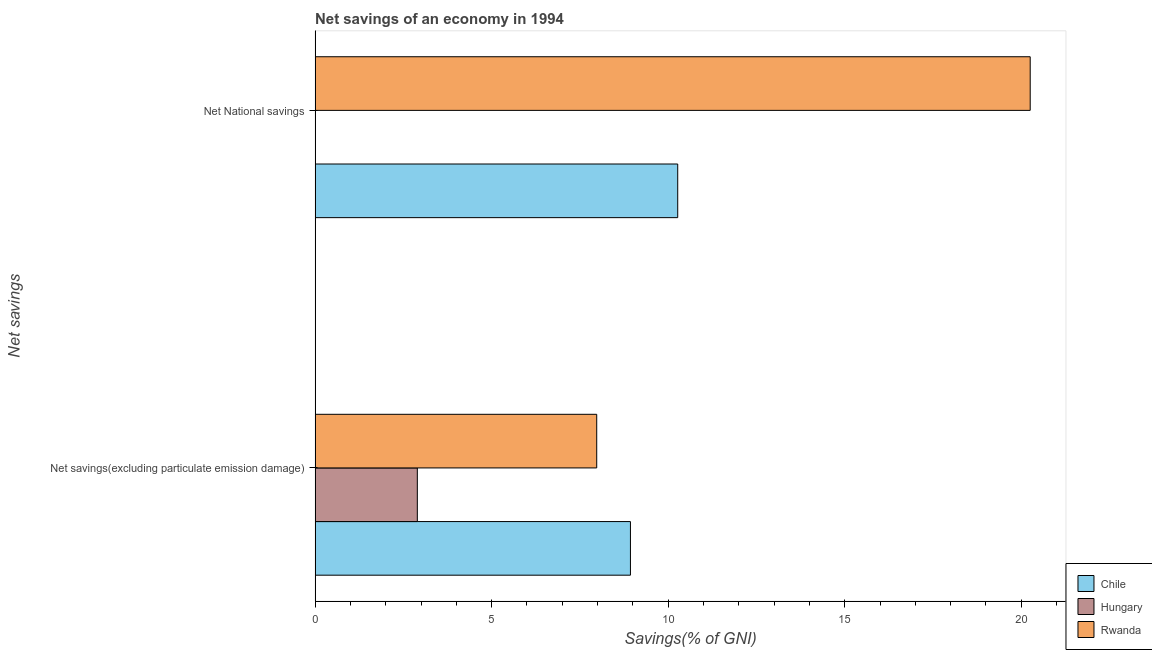Are the number of bars per tick equal to the number of legend labels?
Provide a succinct answer. No. How many bars are there on the 2nd tick from the bottom?
Your answer should be compact. 2. What is the label of the 1st group of bars from the top?
Offer a terse response. Net National savings. What is the net national savings in Chile?
Give a very brief answer. 10.27. Across all countries, what is the maximum net savings(excluding particulate emission damage)?
Provide a succinct answer. 8.93. Across all countries, what is the minimum net national savings?
Offer a terse response. 0. In which country was the net savings(excluding particulate emission damage) maximum?
Keep it short and to the point. Chile. What is the total net savings(excluding particulate emission damage) in the graph?
Your answer should be compact. 19.8. What is the difference between the net national savings in Rwanda and that in Chile?
Give a very brief answer. 9.98. What is the difference between the net national savings in Chile and the net savings(excluding particulate emission damage) in Hungary?
Your response must be concise. 7.37. What is the average net savings(excluding particulate emission damage) per country?
Your answer should be very brief. 6.6. What is the difference between the net savings(excluding particulate emission damage) and net national savings in Rwanda?
Make the answer very short. -12.28. In how many countries, is the net savings(excluding particulate emission damage) greater than 12 %?
Keep it short and to the point. 0. What is the ratio of the net national savings in Chile to that in Rwanda?
Make the answer very short. 0.51. Is the net national savings in Chile less than that in Rwanda?
Your response must be concise. Yes. In how many countries, is the net national savings greater than the average net national savings taken over all countries?
Make the answer very short. 2. Are all the bars in the graph horizontal?
Provide a short and direct response. Yes. What is the difference between two consecutive major ticks on the X-axis?
Offer a terse response. 5. Does the graph contain any zero values?
Offer a very short reply. Yes. Does the graph contain grids?
Your answer should be compact. No. What is the title of the graph?
Your response must be concise. Net savings of an economy in 1994. What is the label or title of the X-axis?
Make the answer very short. Savings(% of GNI). What is the label or title of the Y-axis?
Your response must be concise. Net savings. What is the Savings(% of GNI) of Chile in Net savings(excluding particulate emission damage)?
Offer a terse response. 8.93. What is the Savings(% of GNI) in Hungary in Net savings(excluding particulate emission damage)?
Your answer should be compact. 2.9. What is the Savings(% of GNI) of Rwanda in Net savings(excluding particulate emission damage)?
Offer a terse response. 7.98. What is the Savings(% of GNI) of Chile in Net National savings?
Make the answer very short. 10.27. What is the Savings(% of GNI) in Rwanda in Net National savings?
Your answer should be compact. 20.25. Across all Net savings, what is the maximum Savings(% of GNI) in Chile?
Your answer should be compact. 10.27. Across all Net savings, what is the maximum Savings(% of GNI) of Hungary?
Offer a very short reply. 2.9. Across all Net savings, what is the maximum Savings(% of GNI) of Rwanda?
Give a very brief answer. 20.25. Across all Net savings, what is the minimum Savings(% of GNI) in Chile?
Provide a short and direct response. 8.93. Across all Net savings, what is the minimum Savings(% of GNI) of Rwanda?
Give a very brief answer. 7.98. What is the total Savings(% of GNI) in Chile in the graph?
Your answer should be compact. 19.2. What is the total Savings(% of GNI) of Hungary in the graph?
Your answer should be very brief. 2.9. What is the total Savings(% of GNI) of Rwanda in the graph?
Ensure brevity in your answer.  28.23. What is the difference between the Savings(% of GNI) in Chile in Net savings(excluding particulate emission damage) and that in Net National savings?
Make the answer very short. -1.34. What is the difference between the Savings(% of GNI) in Rwanda in Net savings(excluding particulate emission damage) and that in Net National savings?
Provide a succinct answer. -12.28. What is the difference between the Savings(% of GNI) in Chile in Net savings(excluding particulate emission damage) and the Savings(% of GNI) in Rwanda in Net National savings?
Offer a terse response. -11.32. What is the difference between the Savings(% of GNI) in Hungary in Net savings(excluding particulate emission damage) and the Savings(% of GNI) in Rwanda in Net National savings?
Offer a very short reply. -17.36. What is the average Savings(% of GNI) of Chile per Net savings?
Your answer should be compact. 9.6. What is the average Savings(% of GNI) of Hungary per Net savings?
Provide a short and direct response. 1.45. What is the average Savings(% of GNI) of Rwanda per Net savings?
Give a very brief answer. 14.12. What is the difference between the Savings(% of GNI) in Chile and Savings(% of GNI) in Hungary in Net savings(excluding particulate emission damage)?
Your answer should be very brief. 6.04. What is the difference between the Savings(% of GNI) of Chile and Savings(% of GNI) of Rwanda in Net savings(excluding particulate emission damage)?
Make the answer very short. 0.96. What is the difference between the Savings(% of GNI) of Hungary and Savings(% of GNI) of Rwanda in Net savings(excluding particulate emission damage)?
Your answer should be compact. -5.08. What is the difference between the Savings(% of GNI) of Chile and Savings(% of GNI) of Rwanda in Net National savings?
Make the answer very short. -9.98. What is the ratio of the Savings(% of GNI) of Chile in Net savings(excluding particulate emission damage) to that in Net National savings?
Your answer should be compact. 0.87. What is the ratio of the Savings(% of GNI) in Rwanda in Net savings(excluding particulate emission damage) to that in Net National savings?
Your answer should be very brief. 0.39. What is the difference between the highest and the second highest Savings(% of GNI) of Chile?
Keep it short and to the point. 1.34. What is the difference between the highest and the second highest Savings(% of GNI) of Rwanda?
Your response must be concise. 12.28. What is the difference between the highest and the lowest Savings(% of GNI) in Chile?
Provide a short and direct response. 1.34. What is the difference between the highest and the lowest Savings(% of GNI) in Hungary?
Offer a terse response. 2.9. What is the difference between the highest and the lowest Savings(% of GNI) of Rwanda?
Your answer should be very brief. 12.28. 